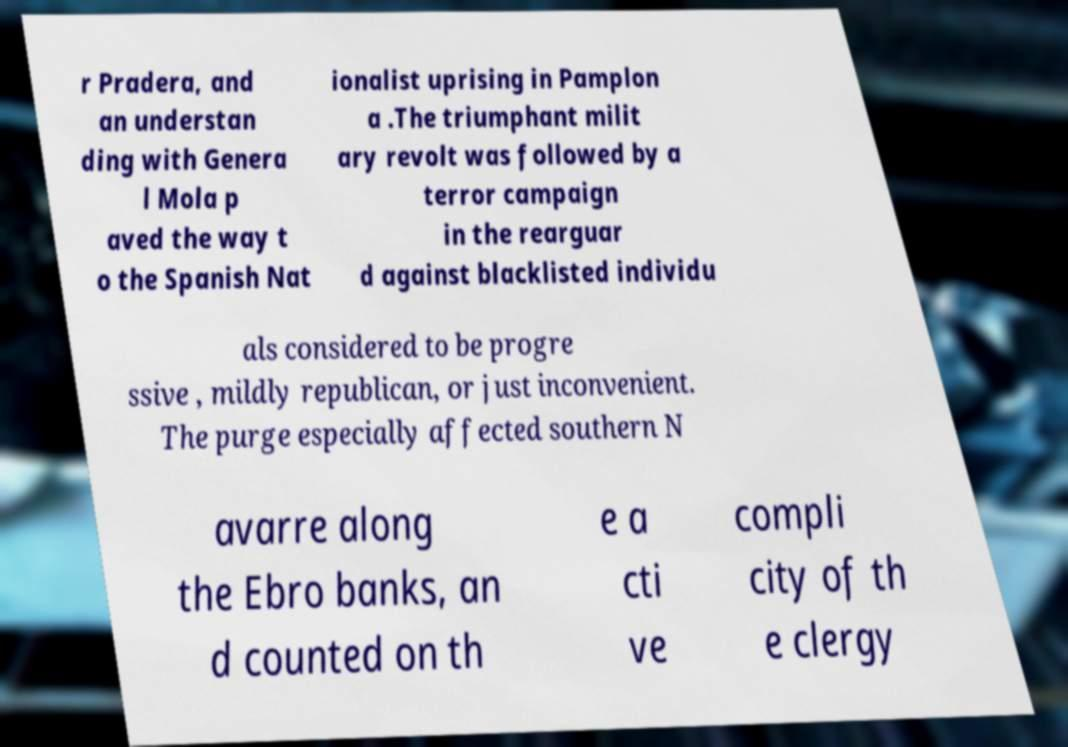There's text embedded in this image that I need extracted. Can you transcribe it verbatim? r Pradera, and an understan ding with Genera l Mola p aved the way t o the Spanish Nat ionalist uprising in Pamplon a .The triumphant milit ary revolt was followed by a terror campaign in the rearguar d against blacklisted individu als considered to be progre ssive , mildly republican, or just inconvenient. The purge especially affected southern N avarre along the Ebro banks, an d counted on th e a cti ve compli city of th e clergy 